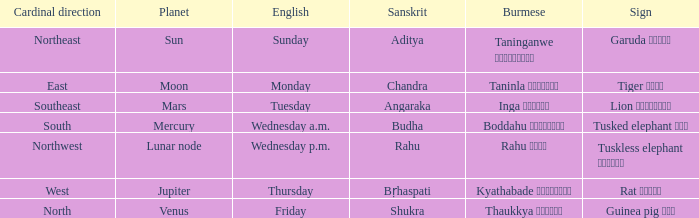What is the cardinal direction associated with Venus? North. 